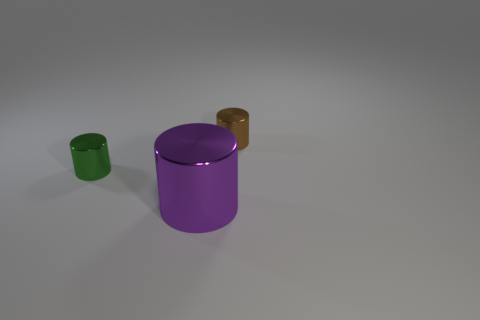Subtract all small cylinders. How many cylinders are left? 1 Subtract 1 cylinders. How many cylinders are left? 2 Add 1 tiny green objects. How many objects exist? 4 Subtract all blue spheres. How many blue cylinders are left? 0 Subtract all blue cylinders. Subtract all metal objects. How many objects are left? 0 Add 3 small brown objects. How many small brown objects are left? 4 Add 3 purple metallic cylinders. How many purple metallic cylinders exist? 4 Subtract 1 green cylinders. How many objects are left? 2 Subtract all cyan cylinders. Subtract all cyan balls. How many cylinders are left? 3 